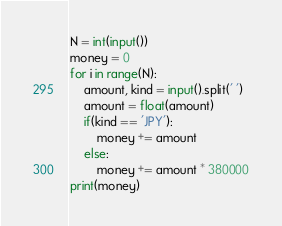Convert code to text. <code><loc_0><loc_0><loc_500><loc_500><_Python_>N = int(input())
money = 0
for i in range(N):
    amount, kind = input().split(' ')
    amount = float(amount)
    if(kind == 'JPY'):
        money += amount
    else:
        money += amount * 380000
print(money)</code> 